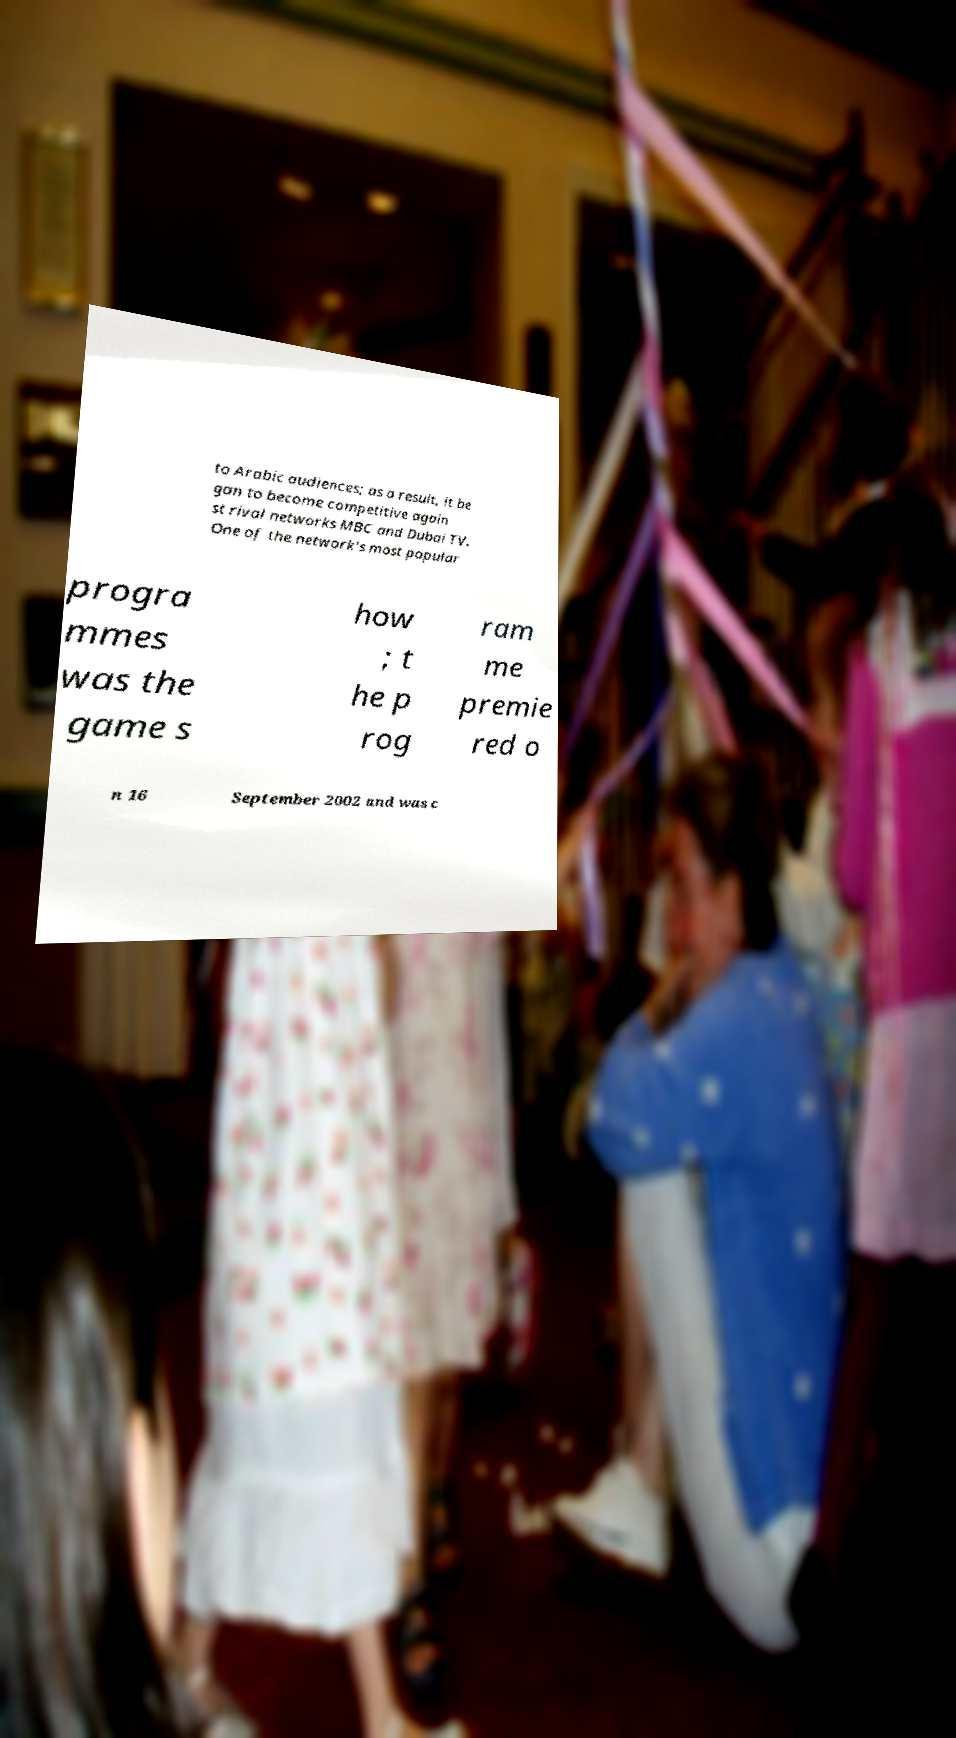Could you extract and type out the text from this image? to Arabic audiences; as a result, it be gan to become competitive again st rival networks MBC and Dubai TV. One of the network's most popular progra mmes was the game s how ; t he p rog ram me premie red o n 16 September 2002 and was c 